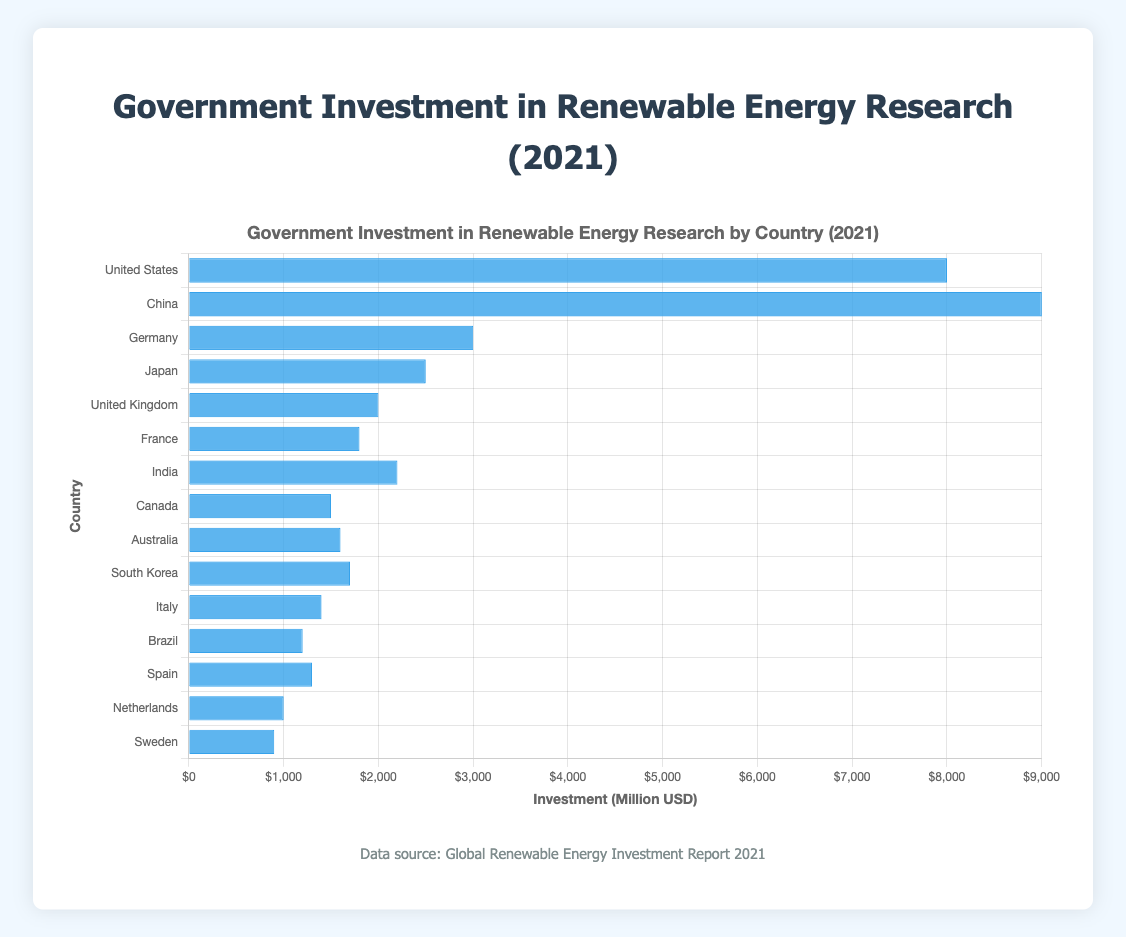Which country has the highest investment in renewable energy research? The bar for China is the longest among all the countries, indicating the highest investment.
Answer: China Which country has the lowest investment in renewable energy research? The bar for Sweden is the shortest among all the countries, indicating the lowest investment.
Answer: Sweden Comparing India and Canada, which country invested more in renewable energy research? The bar representing India is longer than the bar representing Canada, indicating that India invested more.
Answer: India How much more did Germany invest in renewable energy research compared to Spain? Germany invested $3000 million while Spain invested $1300 million. The difference is $3000 million - $1300 million = $1700 million.
Answer: $1700 million What is the total investment by the United States and Japan? The United States invested $8000 million and Japan invested $2500 million. The total investment is $8000 million + $2500 million = $10500 million.
Answer: $10500 million What is the average investment in renewable energy research among France, Brazil, and Italy? The investments are $1800 million (France), $1200 million (Brazil), and $1400 million (Italy). The average is ($1800 million + $1200 million + $1400 million)/3 = $4400 million / 3 = $1466.67 million.
Answer: $1466.67 million Which countries have an investment of at least $2000 million but not more than $3000 million? By looking at the bars, countries that fit this criterion are Germany ($3000 million), India ($2200 million), and Japan ($2500 million).
Answer: Germany, India, Japan What is the percentage increase in investment from Canada to the United Kingdom? Canada's investment is $1500 million and the United Kingdom's investment is $2000 million. The increase is $2000 million - $1500 million = $500 million. The percentage increase is ($500 million / $1500 million) * 100% = 33.33%.
Answer: 33.33% If the total investment by all countries is summed up, what is the overall amount? Summing the investments: $8000 million (USA) + $9000 million (China) + $3000 million (Germany) + $2500 million (Japan) + $2000 million (UK) + $1800 million (France) + $2200 million (India) + $1500 million (Canada) + $1600 million (Australia) + $1700 million (South Korea) + $1400 million (Italy) + $1200 million (Brazil) + $1300 million (Spain) + $1000 million (Netherlands) + $900 million (Sweden) = $43100 million.
Answer: $43100 million Arrange the top five countries in descending order of their investment. The top five countries by investment are China ($9000 million), United States ($8000 million), Germany ($3000 million), Japan ($2500 million), and India ($2200 million).
Answer: China, United States, Germany, Japan, India 